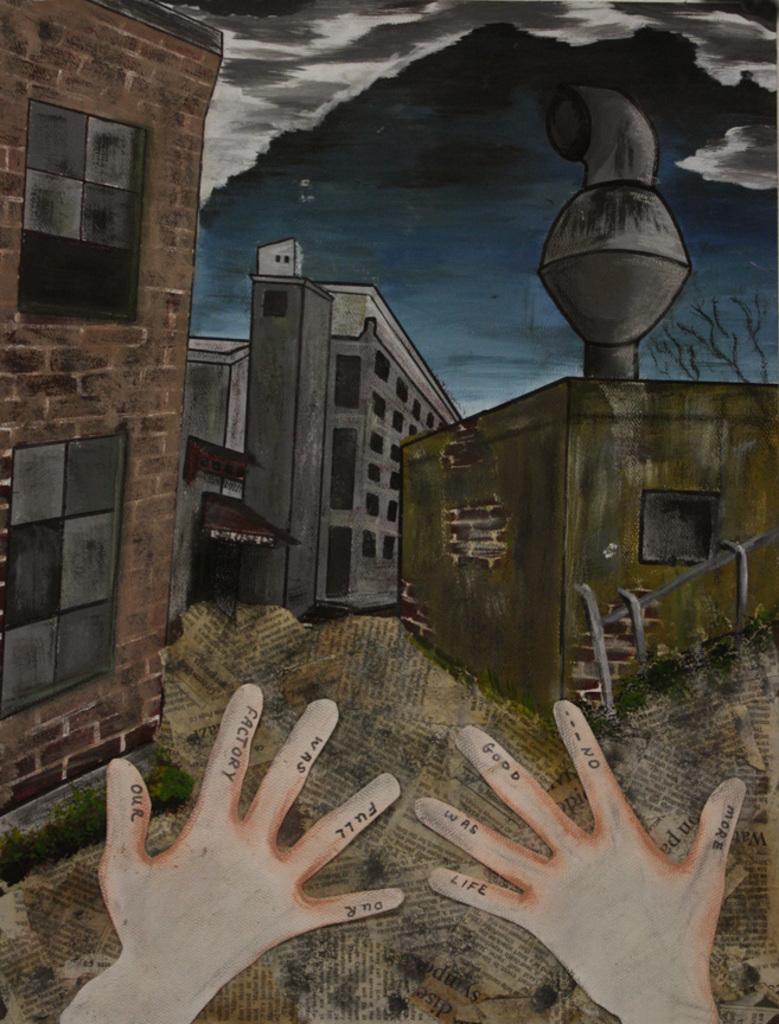Could you give a brief overview of what you see in this image? In this image I can see many buildings which are in brown, ash and green color. In the background I can see the clouds and the sky. I can also see the person's hands in the image. 